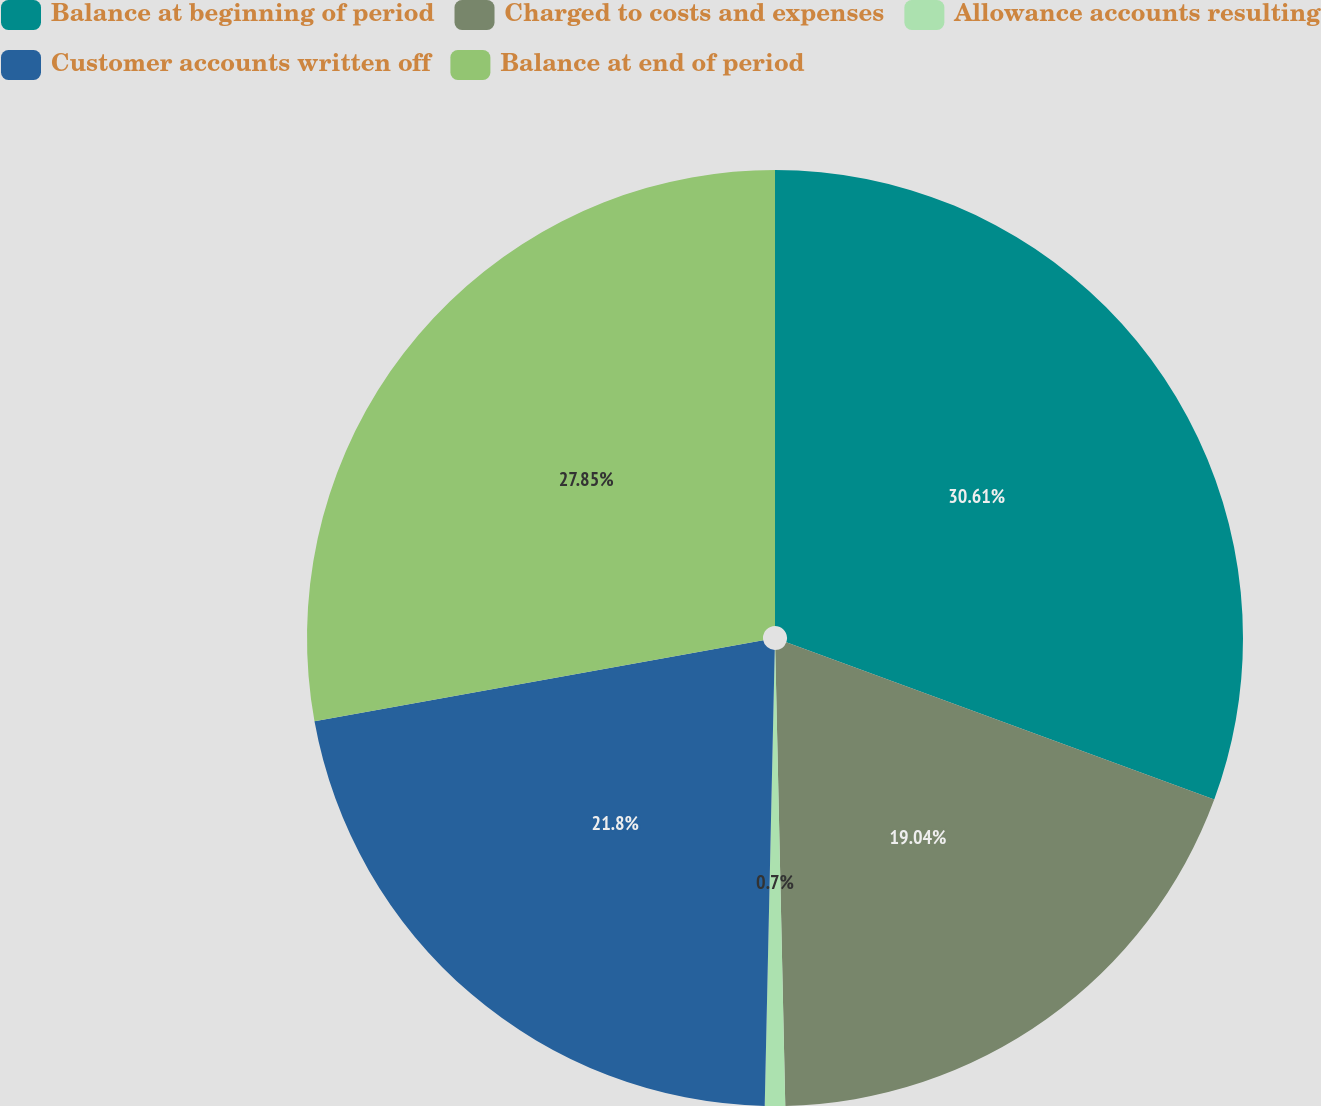<chart> <loc_0><loc_0><loc_500><loc_500><pie_chart><fcel>Balance at beginning of period<fcel>Charged to costs and expenses<fcel>Allowance accounts resulting<fcel>Customer accounts written off<fcel>Balance at end of period<nl><fcel>30.61%<fcel>19.04%<fcel>0.7%<fcel>21.8%<fcel>27.85%<nl></chart> 